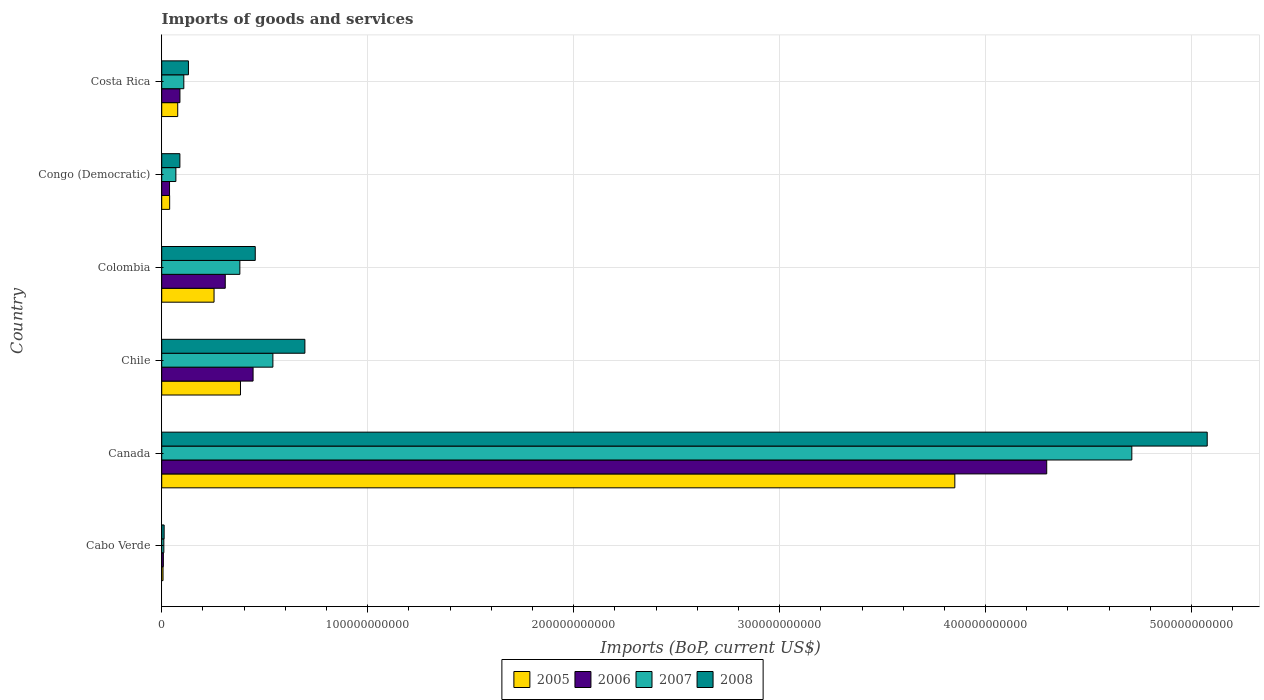What is the label of the 4th group of bars from the top?
Your answer should be compact. Chile. What is the amount spent on imports in 2006 in Colombia?
Provide a succinct answer. 3.09e+1. Across all countries, what is the maximum amount spent on imports in 2006?
Your answer should be compact. 4.30e+11. Across all countries, what is the minimum amount spent on imports in 2008?
Keep it short and to the point. 1.18e+09. In which country was the amount spent on imports in 2006 minimum?
Give a very brief answer. Cabo Verde. What is the total amount spent on imports in 2005 in the graph?
Make the answer very short. 4.61e+11. What is the difference between the amount spent on imports in 2006 in Canada and that in Congo (Democratic)?
Your answer should be compact. 4.26e+11. What is the difference between the amount spent on imports in 2008 in Cabo Verde and the amount spent on imports in 2005 in Canada?
Offer a terse response. -3.84e+11. What is the average amount spent on imports in 2006 per country?
Keep it short and to the point. 8.64e+1. What is the difference between the amount spent on imports in 2008 and amount spent on imports in 2005 in Canada?
Make the answer very short. 1.23e+11. In how many countries, is the amount spent on imports in 2008 greater than 200000000000 US$?
Provide a succinct answer. 1. What is the ratio of the amount spent on imports in 2006 in Chile to that in Colombia?
Keep it short and to the point. 1.44. Is the amount spent on imports in 2008 in Canada less than that in Chile?
Ensure brevity in your answer.  No. What is the difference between the highest and the second highest amount spent on imports in 2008?
Your response must be concise. 4.38e+11. What is the difference between the highest and the lowest amount spent on imports in 2006?
Ensure brevity in your answer.  4.29e+11. What does the 4th bar from the top in Chile represents?
Provide a succinct answer. 2005. Is it the case that in every country, the sum of the amount spent on imports in 2007 and amount spent on imports in 2008 is greater than the amount spent on imports in 2005?
Offer a very short reply. Yes. How many countries are there in the graph?
Give a very brief answer. 6. What is the difference between two consecutive major ticks on the X-axis?
Provide a short and direct response. 1.00e+11. Does the graph contain grids?
Your response must be concise. Yes. How many legend labels are there?
Give a very brief answer. 4. What is the title of the graph?
Provide a short and direct response. Imports of goods and services. What is the label or title of the X-axis?
Offer a terse response. Imports (BoP, current US$). What is the label or title of the Y-axis?
Keep it short and to the point. Country. What is the Imports (BoP, current US$) in 2005 in Cabo Verde?
Keep it short and to the point. 6.42e+08. What is the Imports (BoP, current US$) in 2006 in Cabo Verde?
Offer a terse response. 8.04e+08. What is the Imports (BoP, current US$) of 2007 in Cabo Verde?
Your response must be concise. 1.03e+09. What is the Imports (BoP, current US$) of 2008 in Cabo Verde?
Your answer should be very brief. 1.18e+09. What is the Imports (BoP, current US$) in 2005 in Canada?
Your answer should be compact. 3.85e+11. What is the Imports (BoP, current US$) of 2006 in Canada?
Offer a very short reply. 4.30e+11. What is the Imports (BoP, current US$) in 2007 in Canada?
Your response must be concise. 4.71e+11. What is the Imports (BoP, current US$) in 2008 in Canada?
Provide a succinct answer. 5.08e+11. What is the Imports (BoP, current US$) in 2005 in Chile?
Your answer should be compact. 3.82e+1. What is the Imports (BoP, current US$) in 2006 in Chile?
Provide a short and direct response. 4.44e+1. What is the Imports (BoP, current US$) of 2007 in Chile?
Provide a succinct answer. 5.40e+1. What is the Imports (BoP, current US$) in 2008 in Chile?
Ensure brevity in your answer.  6.95e+1. What is the Imports (BoP, current US$) of 2005 in Colombia?
Provide a short and direct response. 2.54e+1. What is the Imports (BoP, current US$) in 2006 in Colombia?
Your response must be concise. 3.09e+1. What is the Imports (BoP, current US$) of 2007 in Colombia?
Your answer should be compact. 3.79e+1. What is the Imports (BoP, current US$) in 2008 in Colombia?
Your answer should be very brief. 4.54e+1. What is the Imports (BoP, current US$) of 2005 in Congo (Democratic)?
Your response must be concise. 3.86e+09. What is the Imports (BoP, current US$) in 2006 in Congo (Democratic)?
Keep it short and to the point. 3.80e+09. What is the Imports (BoP, current US$) of 2007 in Congo (Democratic)?
Ensure brevity in your answer.  6.87e+09. What is the Imports (BoP, current US$) in 2008 in Congo (Democratic)?
Offer a very short reply. 8.83e+09. What is the Imports (BoP, current US$) of 2005 in Costa Rica?
Provide a short and direct response. 7.77e+09. What is the Imports (BoP, current US$) of 2006 in Costa Rica?
Your response must be concise. 8.85e+09. What is the Imports (BoP, current US$) in 2007 in Costa Rica?
Your answer should be compact. 1.07e+1. What is the Imports (BoP, current US$) of 2008 in Costa Rica?
Provide a succinct answer. 1.30e+1. Across all countries, what is the maximum Imports (BoP, current US$) in 2005?
Give a very brief answer. 3.85e+11. Across all countries, what is the maximum Imports (BoP, current US$) in 2006?
Your response must be concise. 4.30e+11. Across all countries, what is the maximum Imports (BoP, current US$) in 2007?
Your response must be concise. 4.71e+11. Across all countries, what is the maximum Imports (BoP, current US$) of 2008?
Make the answer very short. 5.08e+11. Across all countries, what is the minimum Imports (BoP, current US$) of 2005?
Provide a short and direct response. 6.42e+08. Across all countries, what is the minimum Imports (BoP, current US$) of 2006?
Offer a terse response. 8.04e+08. Across all countries, what is the minimum Imports (BoP, current US$) in 2007?
Provide a short and direct response. 1.03e+09. Across all countries, what is the minimum Imports (BoP, current US$) of 2008?
Provide a succinct answer. 1.18e+09. What is the total Imports (BoP, current US$) of 2005 in the graph?
Give a very brief answer. 4.61e+11. What is the total Imports (BoP, current US$) in 2006 in the graph?
Give a very brief answer. 5.18e+11. What is the total Imports (BoP, current US$) of 2007 in the graph?
Provide a short and direct response. 5.82e+11. What is the total Imports (BoP, current US$) in 2008 in the graph?
Keep it short and to the point. 6.46e+11. What is the difference between the Imports (BoP, current US$) of 2005 in Cabo Verde and that in Canada?
Ensure brevity in your answer.  -3.84e+11. What is the difference between the Imports (BoP, current US$) in 2006 in Cabo Verde and that in Canada?
Keep it short and to the point. -4.29e+11. What is the difference between the Imports (BoP, current US$) of 2007 in Cabo Verde and that in Canada?
Keep it short and to the point. -4.70e+11. What is the difference between the Imports (BoP, current US$) in 2008 in Cabo Verde and that in Canada?
Make the answer very short. -5.06e+11. What is the difference between the Imports (BoP, current US$) of 2005 in Cabo Verde and that in Chile?
Make the answer very short. -3.76e+1. What is the difference between the Imports (BoP, current US$) in 2006 in Cabo Verde and that in Chile?
Provide a short and direct response. -4.36e+1. What is the difference between the Imports (BoP, current US$) in 2007 in Cabo Verde and that in Chile?
Keep it short and to the point. -5.29e+1. What is the difference between the Imports (BoP, current US$) of 2008 in Cabo Verde and that in Chile?
Provide a short and direct response. -6.83e+1. What is the difference between the Imports (BoP, current US$) of 2005 in Cabo Verde and that in Colombia?
Offer a terse response. -2.48e+1. What is the difference between the Imports (BoP, current US$) in 2006 in Cabo Verde and that in Colombia?
Offer a terse response. -3.00e+1. What is the difference between the Imports (BoP, current US$) in 2007 in Cabo Verde and that in Colombia?
Give a very brief answer. -3.69e+1. What is the difference between the Imports (BoP, current US$) of 2008 in Cabo Verde and that in Colombia?
Your answer should be very brief. -4.42e+1. What is the difference between the Imports (BoP, current US$) in 2005 in Cabo Verde and that in Congo (Democratic)?
Your response must be concise. -3.22e+09. What is the difference between the Imports (BoP, current US$) of 2006 in Cabo Verde and that in Congo (Democratic)?
Give a very brief answer. -2.99e+09. What is the difference between the Imports (BoP, current US$) in 2007 in Cabo Verde and that in Congo (Democratic)?
Give a very brief answer. -5.84e+09. What is the difference between the Imports (BoP, current US$) of 2008 in Cabo Verde and that in Congo (Democratic)?
Your answer should be compact. -7.64e+09. What is the difference between the Imports (BoP, current US$) of 2005 in Cabo Verde and that in Costa Rica?
Provide a succinct answer. -7.13e+09. What is the difference between the Imports (BoP, current US$) in 2006 in Cabo Verde and that in Costa Rica?
Offer a very short reply. -8.04e+09. What is the difference between the Imports (BoP, current US$) in 2007 in Cabo Verde and that in Costa Rica?
Give a very brief answer. -9.69e+09. What is the difference between the Imports (BoP, current US$) in 2008 in Cabo Verde and that in Costa Rica?
Offer a very short reply. -1.18e+1. What is the difference between the Imports (BoP, current US$) in 2005 in Canada and that in Chile?
Your response must be concise. 3.47e+11. What is the difference between the Imports (BoP, current US$) in 2006 in Canada and that in Chile?
Your answer should be compact. 3.85e+11. What is the difference between the Imports (BoP, current US$) in 2007 in Canada and that in Chile?
Your response must be concise. 4.17e+11. What is the difference between the Imports (BoP, current US$) in 2008 in Canada and that in Chile?
Your answer should be compact. 4.38e+11. What is the difference between the Imports (BoP, current US$) in 2005 in Canada and that in Colombia?
Keep it short and to the point. 3.60e+11. What is the difference between the Imports (BoP, current US$) in 2006 in Canada and that in Colombia?
Provide a succinct answer. 3.99e+11. What is the difference between the Imports (BoP, current US$) in 2007 in Canada and that in Colombia?
Your answer should be very brief. 4.33e+11. What is the difference between the Imports (BoP, current US$) in 2008 in Canada and that in Colombia?
Keep it short and to the point. 4.62e+11. What is the difference between the Imports (BoP, current US$) of 2005 in Canada and that in Congo (Democratic)?
Your response must be concise. 3.81e+11. What is the difference between the Imports (BoP, current US$) in 2006 in Canada and that in Congo (Democratic)?
Give a very brief answer. 4.26e+11. What is the difference between the Imports (BoP, current US$) of 2007 in Canada and that in Congo (Democratic)?
Your answer should be compact. 4.64e+11. What is the difference between the Imports (BoP, current US$) of 2008 in Canada and that in Congo (Democratic)?
Your response must be concise. 4.99e+11. What is the difference between the Imports (BoP, current US$) in 2005 in Canada and that in Costa Rica?
Your response must be concise. 3.77e+11. What is the difference between the Imports (BoP, current US$) of 2006 in Canada and that in Costa Rica?
Ensure brevity in your answer.  4.21e+11. What is the difference between the Imports (BoP, current US$) of 2007 in Canada and that in Costa Rica?
Offer a terse response. 4.60e+11. What is the difference between the Imports (BoP, current US$) of 2008 in Canada and that in Costa Rica?
Provide a succinct answer. 4.95e+11. What is the difference between the Imports (BoP, current US$) in 2005 in Chile and that in Colombia?
Make the answer very short. 1.28e+1. What is the difference between the Imports (BoP, current US$) of 2006 in Chile and that in Colombia?
Provide a short and direct response. 1.35e+1. What is the difference between the Imports (BoP, current US$) of 2007 in Chile and that in Colombia?
Ensure brevity in your answer.  1.60e+1. What is the difference between the Imports (BoP, current US$) of 2008 in Chile and that in Colombia?
Provide a succinct answer. 2.41e+1. What is the difference between the Imports (BoP, current US$) of 2005 in Chile and that in Congo (Democratic)?
Offer a terse response. 3.44e+1. What is the difference between the Imports (BoP, current US$) of 2006 in Chile and that in Congo (Democratic)?
Make the answer very short. 4.06e+1. What is the difference between the Imports (BoP, current US$) in 2007 in Chile and that in Congo (Democratic)?
Give a very brief answer. 4.71e+1. What is the difference between the Imports (BoP, current US$) in 2008 in Chile and that in Congo (Democratic)?
Give a very brief answer. 6.07e+1. What is the difference between the Imports (BoP, current US$) of 2005 in Chile and that in Costa Rica?
Offer a very short reply. 3.05e+1. What is the difference between the Imports (BoP, current US$) of 2006 in Chile and that in Costa Rica?
Provide a succinct answer. 3.55e+1. What is the difference between the Imports (BoP, current US$) in 2007 in Chile and that in Costa Rica?
Keep it short and to the point. 4.33e+1. What is the difference between the Imports (BoP, current US$) of 2008 in Chile and that in Costa Rica?
Your answer should be very brief. 5.65e+1. What is the difference between the Imports (BoP, current US$) of 2005 in Colombia and that in Congo (Democratic)?
Provide a succinct answer. 2.16e+1. What is the difference between the Imports (BoP, current US$) in 2006 in Colombia and that in Congo (Democratic)?
Provide a short and direct response. 2.71e+1. What is the difference between the Imports (BoP, current US$) in 2007 in Colombia and that in Congo (Democratic)?
Offer a terse response. 3.11e+1. What is the difference between the Imports (BoP, current US$) in 2008 in Colombia and that in Congo (Democratic)?
Provide a short and direct response. 3.66e+1. What is the difference between the Imports (BoP, current US$) of 2005 in Colombia and that in Costa Rica?
Ensure brevity in your answer.  1.76e+1. What is the difference between the Imports (BoP, current US$) in 2006 in Colombia and that in Costa Rica?
Offer a very short reply. 2.20e+1. What is the difference between the Imports (BoP, current US$) in 2007 in Colombia and that in Costa Rica?
Offer a very short reply. 2.72e+1. What is the difference between the Imports (BoP, current US$) of 2008 in Colombia and that in Costa Rica?
Your answer should be compact. 3.24e+1. What is the difference between the Imports (BoP, current US$) in 2005 in Congo (Democratic) and that in Costa Rica?
Provide a succinct answer. -3.91e+09. What is the difference between the Imports (BoP, current US$) in 2006 in Congo (Democratic) and that in Costa Rica?
Keep it short and to the point. -5.05e+09. What is the difference between the Imports (BoP, current US$) in 2007 in Congo (Democratic) and that in Costa Rica?
Make the answer very short. -3.85e+09. What is the difference between the Imports (BoP, current US$) in 2008 in Congo (Democratic) and that in Costa Rica?
Give a very brief answer. -4.15e+09. What is the difference between the Imports (BoP, current US$) of 2005 in Cabo Verde and the Imports (BoP, current US$) of 2006 in Canada?
Your answer should be very brief. -4.29e+11. What is the difference between the Imports (BoP, current US$) in 2005 in Cabo Verde and the Imports (BoP, current US$) in 2007 in Canada?
Offer a terse response. -4.70e+11. What is the difference between the Imports (BoP, current US$) of 2005 in Cabo Verde and the Imports (BoP, current US$) of 2008 in Canada?
Offer a terse response. -5.07e+11. What is the difference between the Imports (BoP, current US$) of 2006 in Cabo Verde and the Imports (BoP, current US$) of 2007 in Canada?
Offer a very short reply. -4.70e+11. What is the difference between the Imports (BoP, current US$) in 2006 in Cabo Verde and the Imports (BoP, current US$) in 2008 in Canada?
Provide a short and direct response. -5.07e+11. What is the difference between the Imports (BoP, current US$) of 2007 in Cabo Verde and the Imports (BoP, current US$) of 2008 in Canada?
Provide a succinct answer. -5.07e+11. What is the difference between the Imports (BoP, current US$) in 2005 in Cabo Verde and the Imports (BoP, current US$) in 2006 in Chile?
Make the answer very short. -4.37e+1. What is the difference between the Imports (BoP, current US$) of 2005 in Cabo Verde and the Imports (BoP, current US$) of 2007 in Chile?
Make the answer very short. -5.33e+1. What is the difference between the Imports (BoP, current US$) in 2005 in Cabo Verde and the Imports (BoP, current US$) in 2008 in Chile?
Give a very brief answer. -6.89e+1. What is the difference between the Imports (BoP, current US$) of 2006 in Cabo Verde and the Imports (BoP, current US$) of 2007 in Chile?
Provide a short and direct response. -5.32e+1. What is the difference between the Imports (BoP, current US$) of 2006 in Cabo Verde and the Imports (BoP, current US$) of 2008 in Chile?
Your answer should be very brief. -6.87e+1. What is the difference between the Imports (BoP, current US$) of 2007 in Cabo Verde and the Imports (BoP, current US$) of 2008 in Chile?
Provide a succinct answer. -6.85e+1. What is the difference between the Imports (BoP, current US$) of 2005 in Cabo Verde and the Imports (BoP, current US$) of 2006 in Colombia?
Keep it short and to the point. -3.02e+1. What is the difference between the Imports (BoP, current US$) in 2005 in Cabo Verde and the Imports (BoP, current US$) in 2007 in Colombia?
Your answer should be compact. -3.73e+1. What is the difference between the Imports (BoP, current US$) of 2005 in Cabo Verde and the Imports (BoP, current US$) of 2008 in Colombia?
Offer a very short reply. -4.48e+1. What is the difference between the Imports (BoP, current US$) in 2006 in Cabo Verde and the Imports (BoP, current US$) in 2007 in Colombia?
Provide a short and direct response. -3.71e+1. What is the difference between the Imports (BoP, current US$) of 2006 in Cabo Verde and the Imports (BoP, current US$) of 2008 in Colombia?
Your response must be concise. -4.46e+1. What is the difference between the Imports (BoP, current US$) of 2007 in Cabo Verde and the Imports (BoP, current US$) of 2008 in Colombia?
Provide a short and direct response. -4.44e+1. What is the difference between the Imports (BoP, current US$) in 2005 in Cabo Verde and the Imports (BoP, current US$) in 2006 in Congo (Democratic)?
Provide a succinct answer. -3.16e+09. What is the difference between the Imports (BoP, current US$) in 2005 in Cabo Verde and the Imports (BoP, current US$) in 2007 in Congo (Democratic)?
Offer a terse response. -6.23e+09. What is the difference between the Imports (BoP, current US$) of 2005 in Cabo Verde and the Imports (BoP, current US$) of 2008 in Congo (Democratic)?
Your answer should be compact. -8.18e+09. What is the difference between the Imports (BoP, current US$) of 2006 in Cabo Verde and the Imports (BoP, current US$) of 2007 in Congo (Democratic)?
Offer a very short reply. -6.07e+09. What is the difference between the Imports (BoP, current US$) of 2006 in Cabo Verde and the Imports (BoP, current US$) of 2008 in Congo (Democratic)?
Offer a very short reply. -8.02e+09. What is the difference between the Imports (BoP, current US$) of 2007 in Cabo Verde and the Imports (BoP, current US$) of 2008 in Congo (Democratic)?
Provide a short and direct response. -7.79e+09. What is the difference between the Imports (BoP, current US$) of 2005 in Cabo Verde and the Imports (BoP, current US$) of 2006 in Costa Rica?
Provide a short and direct response. -8.20e+09. What is the difference between the Imports (BoP, current US$) of 2005 in Cabo Verde and the Imports (BoP, current US$) of 2007 in Costa Rica?
Your answer should be very brief. -1.01e+1. What is the difference between the Imports (BoP, current US$) in 2005 in Cabo Verde and the Imports (BoP, current US$) in 2008 in Costa Rica?
Your answer should be very brief. -1.23e+1. What is the difference between the Imports (BoP, current US$) in 2006 in Cabo Verde and the Imports (BoP, current US$) in 2007 in Costa Rica?
Give a very brief answer. -9.92e+09. What is the difference between the Imports (BoP, current US$) of 2006 in Cabo Verde and the Imports (BoP, current US$) of 2008 in Costa Rica?
Give a very brief answer. -1.22e+1. What is the difference between the Imports (BoP, current US$) in 2007 in Cabo Verde and the Imports (BoP, current US$) in 2008 in Costa Rica?
Your answer should be compact. -1.19e+1. What is the difference between the Imports (BoP, current US$) in 2005 in Canada and the Imports (BoP, current US$) in 2006 in Chile?
Provide a succinct answer. 3.41e+11. What is the difference between the Imports (BoP, current US$) in 2005 in Canada and the Imports (BoP, current US$) in 2007 in Chile?
Provide a short and direct response. 3.31e+11. What is the difference between the Imports (BoP, current US$) in 2005 in Canada and the Imports (BoP, current US$) in 2008 in Chile?
Make the answer very short. 3.16e+11. What is the difference between the Imports (BoP, current US$) in 2006 in Canada and the Imports (BoP, current US$) in 2007 in Chile?
Give a very brief answer. 3.76e+11. What is the difference between the Imports (BoP, current US$) of 2006 in Canada and the Imports (BoP, current US$) of 2008 in Chile?
Your answer should be compact. 3.60e+11. What is the difference between the Imports (BoP, current US$) in 2007 in Canada and the Imports (BoP, current US$) in 2008 in Chile?
Provide a short and direct response. 4.01e+11. What is the difference between the Imports (BoP, current US$) of 2005 in Canada and the Imports (BoP, current US$) of 2006 in Colombia?
Keep it short and to the point. 3.54e+11. What is the difference between the Imports (BoP, current US$) of 2005 in Canada and the Imports (BoP, current US$) of 2007 in Colombia?
Provide a succinct answer. 3.47e+11. What is the difference between the Imports (BoP, current US$) of 2005 in Canada and the Imports (BoP, current US$) of 2008 in Colombia?
Provide a short and direct response. 3.40e+11. What is the difference between the Imports (BoP, current US$) in 2006 in Canada and the Imports (BoP, current US$) in 2007 in Colombia?
Provide a succinct answer. 3.92e+11. What is the difference between the Imports (BoP, current US$) in 2006 in Canada and the Imports (BoP, current US$) in 2008 in Colombia?
Give a very brief answer. 3.84e+11. What is the difference between the Imports (BoP, current US$) in 2007 in Canada and the Imports (BoP, current US$) in 2008 in Colombia?
Give a very brief answer. 4.26e+11. What is the difference between the Imports (BoP, current US$) in 2005 in Canada and the Imports (BoP, current US$) in 2006 in Congo (Democratic)?
Offer a very short reply. 3.81e+11. What is the difference between the Imports (BoP, current US$) of 2005 in Canada and the Imports (BoP, current US$) of 2007 in Congo (Democratic)?
Give a very brief answer. 3.78e+11. What is the difference between the Imports (BoP, current US$) of 2005 in Canada and the Imports (BoP, current US$) of 2008 in Congo (Democratic)?
Your answer should be very brief. 3.76e+11. What is the difference between the Imports (BoP, current US$) in 2006 in Canada and the Imports (BoP, current US$) in 2007 in Congo (Democratic)?
Your answer should be very brief. 4.23e+11. What is the difference between the Imports (BoP, current US$) in 2006 in Canada and the Imports (BoP, current US$) in 2008 in Congo (Democratic)?
Make the answer very short. 4.21e+11. What is the difference between the Imports (BoP, current US$) in 2007 in Canada and the Imports (BoP, current US$) in 2008 in Congo (Democratic)?
Keep it short and to the point. 4.62e+11. What is the difference between the Imports (BoP, current US$) of 2005 in Canada and the Imports (BoP, current US$) of 2006 in Costa Rica?
Give a very brief answer. 3.76e+11. What is the difference between the Imports (BoP, current US$) of 2005 in Canada and the Imports (BoP, current US$) of 2007 in Costa Rica?
Ensure brevity in your answer.  3.74e+11. What is the difference between the Imports (BoP, current US$) of 2005 in Canada and the Imports (BoP, current US$) of 2008 in Costa Rica?
Offer a terse response. 3.72e+11. What is the difference between the Imports (BoP, current US$) of 2006 in Canada and the Imports (BoP, current US$) of 2007 in Costa Rica?
Offer a very short reply. 4.19e+11. What is the difference between the Imports (BoP, current US$) in 2006 in Canada and the Imports (BoP, current US$) in 2008 in Costa Rica?
Provide a succinct answer. 4.17e+11. What is the difference between the Imports (BoP, current US$) in 2007 in Canada and the Imports (BoP, current US$) in 2008 in Costa Rica?
Offer a very short reply. 4.58e+11. What is the difference between the Imports (BoP, current US$) of 2005 in Chile and the Imports (BoP, current US$) of 2006 in Colombia?
Your response must be concise. 7.40e+09. What is the difference between the Imports (BoP, current US$) in 2005 in Chile and the Imports (BoP, current US$) in 2007 in Colombia?
Your answer should be very brief. 3.07e+08. What is the difference between the Imports (BoP, current US$) of 2005 in Chile and the Imports (BoP, current US$) of 2008 in Colombia?
Your answer should be compact. -7.17e+09. What is the difference between the Imports (BoP, current US$) of 2006 in Chile and the Imports (BoP, current US$) of 2007 in Colombia?
Your answer should be compact. 6.42e+09. What is the difference between the Imports (BoP, current US$) in 2006 in Chile and the Imports (BoP, current US$) in 2008 in Colombia?
Your response must be concise. -1.05e+09. What is the difference between the Imports (BoP, current US$) of 2007 in Chile and the Imports (BoP, current US$) of 2008 in Colombia?
Provide a short and direct response. 8.57e+09. What is the difference between the Imports (BoP, current US$) in 2005 in Chile and the Imports (BoP, current US$) in 2006 in Congo (Democratic)?
Your answer should be compact. 3.45e+1. What is the difference between the Imports (BoP, current US$) of 2005 in Chile and the Imports (BoP, current US$) of 2007 in Congo (Democratic)?
Ensure brevity in your answer.  3.14e+1. What is the difference between the Imports (BoP, current US$) of 2005 in Chile and the Imports (BoP, current US$) of 2008 in Congo (Democratic)?
Your answer should be compact. 2.94e+1. What is the difference between the Imports (BoP, current US$) of 2006 in Chile and the Imports (BoP, current US$) of 2007 in Congo (Democratic)?
Make the answer very short. 3.75e+1. What is the difference between the Imports (BoP, current US$) in 2006 in Chile and the Imports (BoP, current US$) in 2008 in Congo (Democratic)?
Offer a terse response. 3.55e+1. What is the difference between the Imports (BoP, current US$) in 2007 in Chile and the Imports (BoP, current US$) in 2008 in Congo (Democratic)?
Provide a succinct answer. 4.52e+1. What is the difference between the Imports (BoP, current US$) of 2005 in Chile and the Imports (BoP, current US$) of 2006 in Costa Rica?
Ensure brevity in your answer.  2.94e+1. What is the difference between the Imports (BoP, current US$) of 2005 in Chile and the Imports (BoP, current US$) of 2007 in Costa Rica?
Keep it short and to the point. 2.75e+1. What is the difference between the Imports (BoP, current US$) in 2005 in Chile and the Imports (BoP, current US$) in 2008 in Costa Rica?
Keep it short and to the point. 2.53e+1. What is the difference between the Imports (BoP, current US$) in 2006 in Chile and the Imports (BoP, current US$) in 2007 in Costa Rica?
Give a very brief answer. 3.36e+1. What is the difference between the Imports (BoP, current US$) in 2006 in Chile and the Imports (BoP, current US$) in 2008 in Costa Rica?
Ensure brevity in your answer.  3.14e+1. What is the difference between the Imports (BoP, current US$) of 2007 in Chile and the Imports (BoP, current US$) of 2008 in Costa Rica?
Your answer should be very brief. 4.10e+1. What is the difference between the Imports (BoP, current US$) of 2005 in Colombia and the Imports (BoP, current US$) of 2006 in Congo (Democratic)?
Offer a very short reply. 2.16e+1. What is the difference between the Imports (BoP, current US$) in 2005 in Colombia and the Imports (BoP, current US$) in 2007 in Congo (Democratic)?
Provide a short and direct response. 1.85e+1. What is the difference between the Imports (BoP, current US$) in 2005 in Colombia and the Imports (BoP, current US$) in 2008 in Congo (Democratic)?
Your response must be concise. 1.66e+1. What is the difference between the Imports (BoP, current US$) of 2006 in Colombia and the Imports (BoP, current US$) of 2007 in Congo (Democratic)?
Offer a terse response. 2.40e+1. What is the difference between the Imports (BoP, current US$) in 2006 in Colombia and the Imports (BoP, current US$) in 2008 in Congo (Democratic)?
Your answer should be very brief. 2.20e+1. What is the difference between the Imports (BoP, current US$) in 2007 in Colombia and the Imports (BoP, current US$) in 2008 in Congo (Democratic)?
Ensure brevity in your answer.  2.91e+1. What is the difference between the Imports (BoP, current US$) of 2005 in Colombia and the Imports (BoP, current US$) of 2006 in Costa Rica?
Provide a short and direct response. 1.66e+1. What is the difference between the Imports (BoP, current US$) of 2005 in Colombia and the Imports (BoP, current US$) of 2007 in Costa Rica?
Offer a very short reply. 1.47e+1. What is the difference between the Imports (BoP, current US$) in 2005 in Colombia and the Imports (BoP, current US$) in 2008 in Costa Rica?
Offer a very short reply. 1.24e+1. What is the difference between the Imports (BoP, current US$) of 2006 in Colombia and the Imports (BoP, current US$) of 2007 in Costa Rica?
Offer a terse response. 2.01e+1. What is the difference between the Imports (BoP, current US$) in 2006 in Colombia and the Imports (BoP, current US$) in 2008 in Costa Rica?
Your answer should be very brief. 1.79e+1. What is the difference between the Imports (BoP, current US$) in 2007 in Colombia and the Imports (BoP, current US$) in 2008 in Costa Rica?
Give a very brief answer. 2.50e+1. What is the difference between the Imports (BoP, current US$) of 2005 in Congo (Democratic) and the Imports (BoP, current US$) of 2006 in Costa Rica?
Provide a succinct answer. -4.99e+09. What is the difference between the Imports (BoP, current US$) of 2005 in Congo (Democratic) and the Imports (BoP, current US$) of 2007 in Costa Rica?
Offer a terse response. -6.87e+09. What is the difference between the Imports (BoP, current US$) of 2005 in Congo (Democratic) and the Imports (BoP, current US$) of 2008 in Costa Rica?
Your response must be concise. -9.12e+09. What is the difference between the Imports (BoP, current US$) of 2006 in Congo (Democratic) and the Imports (BoP, current US$) of 2007 in Costa Rica?
Your answer should be compact. -6.93e+09. What is the difference between the Imports (BoP, current US$) in 2006 in Congo (Democratic) and the Imports (BoP, current US$) in 2008 in Costa Rica?
Make the answer very short. -9.18e+09. What is the difference between the Imports (BoP, current US$) in 2007 in Congo (Democratic) and the Imports (BoP, current US$) in 2008 in Costa Rica?
Provide a short and direct response. -6.10e+09. What is the average Imports (BoP, current US$) in 2005 per country?
Your answer should be very brief. 7.68e+1. What is the average Imports (BoP, current US$) in 2006 per country?
Provide a short and direct response. 8.64e+1. What is the average Imports (BoP, current US$) in 2007 per country?
Your answer should be compact. 9.69e+1. What is the average Imports (BoP, current US$) of 2008 per country?
Provide a short and direct response. 1.08e+11. What is the difference between the Imports (BoP, current US$) of 2005 and Imports (BoP, current US$) of 2006 in Cabo Verde?
Offer a very short reply. -1.62e+08. What is the difference between the Imports (BoP, current US$) of 2005 and Imports (BoP, current US$) of 2007 in Cabo Verde?
Provide a short and direct response. -3.92e+08. What is the difference between the Imports (BoP, current US$) in 2005 and Imports (BoP, current US$) in 2008 in Cabo Verde?
Offer a terse response. -5.41e+08. What is the difference between the Imports (BoP, current US$) of 2006 and Imports (BoP, current US$) of 2007 in Cabo Verde?
Your answer should be very brief. -2.30e+08. What is the difference between the Imports (BoP, current US$) in 2006 and Imports (BoP, current US$) in 2008 in Cabo Verde?
Offer a very short reply. -3.79e+08. What is the difference between the Imports (BoP, current US$) in 2007 and Imports (BoP, current US$) in 2008 in Cabo Verde?
Your answer should be very brief. -1.50e+08. What is the difference between the Imports (BoP, current US$) of 2005 and Imports (BoP, current US$) of 2006 in Canada?
Your answer should be compact. -4.46e+1. What is the difference between the Imports (BoP, current US$) in 2005 and Imports (BoP, current US$) in 2007 in Canada?
Offer a terse response. -8.59e+1. What is the difference between the Imports (BoP, current US$) of 2005 and Imports (BoP, current US$) of 2008 in Canada?
Offer a terse response. -1.23e+11. What is the difference between the Imports (BoP, current US$) in 2006 and Imports (BoP, current US$) in 2007 in Canada?
Provide a succinct answer. -4.13e+1. What is the difference between the Imports (BoP, current US$) of 2006 and Imports (BoP, current US$) of 2008 in Canada?
Give a very brief answer. -7.79e+1. What is the difference between the Imports (BoP, current US$) of 2007 and Imports (BoP, current US$) of 2008 in Canada?
Provide a short and direct response. -3.66e+1. What is the difference between the Imports (BoP, current US$) in 2005 and Imports (BoP, current US$) in 2006 in Chile?
Your answer should be very brief. -6.11e+09. What is the difference between the Imports (BoP, current US$) in 2005 and Imports (BoP, current US$) in 2007 in Chile?
Provide a short and direct response. -1.57e+1. What is the difference between the Imports (BoP, current US$) in 2005 and Imports (BoP, current US$) in 2008 in Chile?
Offer a terse response. -3.13e+1. What is the difference between the Imports (BoP, current US$) in 2006 and Imports (BoP, current US$) in 2007 in Chile?
Offer a terse response. -9.62e+09. What is the difference between the Imports (BoP, current US$) in 2006 and Imports (BoP, current US$) in 2008 in Chile?
Ensure brevity in your answer.  -2.52e+1. What is the difference between the Imports (BoP, current US$) of 2007 and Imports (BoP, current US$) of 2008 in Chile?
Your answer should be compact. -1.55e+1. What is the difference between the Imports (BoP, current US$) in 2005 and Imports (BoP, current US$) in 2006 in Colombia?
Your answer should be very brief. -5.44e+09. What is the difference between the Imports (BoP, current US$) in 2005 and Imports (BoP, current US$) in 2007 in Colombia?
Offer a terse response. -1.25e+1. What is the difference between the Imports (BoP, current US$) in 2005 and Imports (BoP, current US$) in 2008 in Colombia?
Give a very brief answer. -2.00e+1. What is the difference between the Imports (BoP, current US$) in 2006 and Imports (BoP, current US$) in 2007 in Colombia?
Offer a terse response. -7.09e+09. What is the difference between the Imports (BoP, current US$) in 2006 and Imports (BoP, current US$) in 2008 in Colombia?
Provide a succinct answer. -1.46e+1. What is the difference between the Imports (BoP, current US$) in 2007 and Imports (BoP, current US$) in 2008 in Colombia?
Ensure brevity in your answer.  -7.47e+09. What is the difference between the Imports (BoP, current US$) of 2005 and Imports (BoP, current US$) of 2006 in Congo (Democratic)?
Give a very brief answer. 6.22e+07. What is the difference between the Imports (BoP, current US$) in 2005 and Imports (BoP, current US$) in 2007 in Congo (Democratic)?
Make the answer very short. -3.02e+09. What is the difference between the Imports (BoP, current US$) in 2005 and Imports (BoP, current US$) in 2008 in Congo (Democratic)?
Ensure brevity in your answer.  -4.97e+09. What is the difference between the Imports (BoP, current US$) of 2006 and Imports (BoP, current US$) of 2007 in Congo (Democratic)?
Provide a short and direct response. -3.08e+09. What is the difference between the Imports (BoP, current US$) of 2006 and Imports (BoP, current US$) of 2008 in Congo (Democratic)?
Provide a succinct answer. -5.03e+09. What is the difference between the Imports (BoP, current US$) in 2007 and Imports (BoP, current US$) in 2008 in Congo (Democratic)?
Provide a succinct answer. -1.95e+09. What is the difference between the Imports (BoP, current US$) of 2005 and Imports (BoP, current US$) of 2006 in Costa Rica?
Keep it short and to the point. -1.07e+09. What is the difference between the Imports (BoP, current US$) in 2005 and Imports (BoP, current US$) in 2007 in Costa Rica?
Provide a succinct answer. -2.96e+09. What is the difference between the Imports (BoP, current US$) of 2005 and Imports (BoP, current US$) of 2008 in Costa Rica?
Ensure brevity in your answer.  -5.21e+09. What is the difference between the Imports (BoP, current US$) of 2006 and Imports (BoP, current US$) of 2007 in Costa Rica?
Ensure brevity in your answer.  -1.88e+09. What is the difference between the Imports (BoP, current US$) in 2006 and Imports (BoP, current US$) in 2008 in Costa Rica?
Offer a terse response. -4.13e+09. What is the difference between the Imports (BoP, current US$) in 2007 and Imports (BoP, current US$) in 2008 in Costa Rica?
Your answer should be compact. -2.25e+09. What is the ratio of the Imports (BoP, current US$) of 2005 in Cabo Verde to that in Canada?
Offer a very short reply. 0. What is the ratio of the Imports (BoP, current US$) of 2006 in Cabo Verde to that in Canada?
Provide a succinct answer. 0. What is the ratio of the Imports (BoP, current US$) in 2007 in Cabo Verde to that in Canada?
Ensure brevity in your answer.  0. What is the ratio of the Imports (BoP, current US$) of 2008 in Cabo Verde to that in Canada?
Provide a short and direct response. 0. What is the ratio of the Imports (BoP, current US$) of 2005 in Cabo Verde to that in Chile?
Provide a succinct answer. 0.02. What is the ratio of the Imports (BoP, current US$) of 2006 in Cabo Verde to that in Chile?
Ensure brevity in your answer.  0.02. What is the ratio of the Imports (BoP, current US$) of 2007 in Cabo Verde to that in Chile?
Give a very brief answer. 0.02. What is the ratio of the Imports (BoP, current US$) in 2008 in Cabo Verde to that in Chile?
Provide a succinct answer. 0.02. What is the ratio of the Imports (BoP, current US$) in 2005 in Cabo Verde to that in Colombia?
Offer a terse response. 0.03. What is the ratio of the Imports (BoP, current US$) in 2006 in Cabo Verde to that in Colombia?
Provide a short and direct response. 0.03. What is the ratio of the Imports (BoP, current US$) of 2007 in Cabo Verde to that in Colombia?
Your answer should be very brief. 0.03. What is the ratio of the Imports (BoP, current US$) in 2008 in Cabo Verde to that in Colombia?
Offer a very short reply. 0.03. What is the ratio of the Imports (BoP, current US$) in 2005 in Cabo Verde to that in Congo (Democratic)?
Your answer should be very brief. 0.17. What is the ratio of the Imports (BoP, current US$) in 2006 in Cabo Verde to that in Congo (Democratic)?
Keep it short and to the point. 0.21. What is the ratio of the Imports (BoP, current US$) in 2007 in Cabo Verde to that in Congo (Democratic)?
Your answer should be compact. 0.15. What is the ratio of the Imports (BoP, current US$) in 2008 in Cabo Verde to that in Congo (Democratic)?
Keep it short and to the point. 0.13. What is the ratio of the Imports (BoP, current US$) of 2005 in Cabo Verde to that in Costa Rica?
Ensure brevity in your answer.  0.08. What is the ratio of the Imports (BoP, current US$) of 2006 in Cabo Verde to that in Costa Rica?
Your response must be concise. 0.09. What is the ratio of the Imports (BoP, current US$) in 2007 in Cabo Verde to that in Costa Rica?
Make the answer very short. 0.1. What is the ratio of the Imports (BoP, current US$) of 2008 in Cabo Verde to that in Costa Rica?
Keep it short and to the point. 0.09. What is the ratio of the Imports (BoP, current US$) in 2005 in Canada to that in Chile?
Provide a succinct answer. 10.07. What is the ratio of the Imports (BoP, current US$) of 2006 in Canada to that in Chile?
Your answer should be compact. 9.69. What is the ratio of the Imports (BoP, current US$) of 2007 in Canada to that in Chile?
Make the answer very short. 8.73. What is the ratio of the Imports (BoP, current US$) of 2008 in Canada to that in Chile?
Ensure brevity in your answer.  7.3. What is the ratio of the Imports (BoP, current US$) in 2005 in Canada to that in Colombia?
Ensure brevity in your answer.  15.15. What is the ratio of the Imports (BoP, current US$) of 2006 in Canada to that in Colombia?
Your answer should be compact. 13.93. What is the ratio of the Imports (BoP, current US$) in 2007 in Canada to that in Colombia?
Your answer should be very brief. 12.41. What is the ratio of the Imports (BoP, current US$) of 2008 in Canada to that in Colombia?
Your answer should be compact. 11.18. What is the ratio of the Imports (BoP, current US$) of 2005 in Canada to that in Congo (Democratic)?
Ensure brevity in your answer.  99.77. What is the ratio of the Imports (BoP, current US$) of 2006 in Canada to that in Congo (Democratic)?
Provide a succinct answer. 113.15. What is the ratio of the Imports (BoP, current US$) of 2007 in Canada to that in Congo (Democratic)?
Your answer should be very brief. 68.51. What is the ratio of the Imports (BoP, current US$) in 2008 in Canada to that in Congo (Democratic)?
Give a very brief answer. 57.52. What is the ratio of the Imports (BoP, current US$) of 2005 in Canada to that in Costa Rica?
Give a very brief answer. 49.55. What is the ratio of the Imports (BoP, current US$) of 2006 in Canada to that in Costa Rica?
Provide a succinct answer. 48.57. What is the ratio of the Imports (BoP, current US$) of 2007 in Canada to that in Costa Rica?
Provide a succinct answer. 43.9. What is the ratio of the Imports (BoP, current US$) of 2008 in Canada to that in Costa Rica?
Offer a terse response. 39.11. What is the ratio of the Imports (BoP, current US$) of 2005 in Chile to that in Colombia?
Keep it short and to the point. 1.51. What is the ratio of the Imports (BoP, current US$) in 2006 in Chile to that in Colombia?
Make the answer very short. 1.44. What is the ratio of the Imports (BoP, current US$) of 2007 in Chile to that in Colombia?
Give a very brief answer. 1.42. What is the ratio of the Imports (BoP, current US$) in 2008 in Chile to that in Colombia?
Keep it short and to the point. 1.53. What is the ratio of the Imports (BoP, current US$) of 2005 in Chile to that in Congo (Democratic)?
Give a very brief answer. 9.91. What is the ratio of the Imports (BoP, current US$) in 2006 in Chile to that in Congo (Democratic)?
Your response must be concise. 11.68. What is the ratio of the Imports (BoP, current US$) in 2007 in Chile to that in Congo (Democratic)?
Keep it short and to the point. 7.85. What is the ratio of the Imports (BoP, current US$) of 2008 in Chile to that in Congo (Democratic)?
Make the answer very short. 7.88. What is the ratio of the Imports (BoP, current US$) of 2005 in Chile to that in Costa Rica?
Keep it short and to the point. 4.92. What is the ratio of the Imports (BoP, current US$) of 2006 in Chile to that in Costa Rica?
Ensure brevity in your answer.  5.01. What is the ratio of the Imports (BoP, current US$) in 2007 in Chile to that in Costa Rica?
Your answer should be very brief. 5.03. What is the ratio of the Imports (BoP, current US$) in 2008 in Chile to that in Costa Rica?
Your answer should be very brief. 5.36. What is the ratio of the Imports (BoP, current US$) of 2005 in Colombia to that in Congo (Democratic)?
Offer a terse response. 6.58. What is the ratio of the Imports (BoP, current US$) in 2006 in Colombia to that in Congo (Democratic)?
Offer a very short reply. 8.12. What is the ratio of the Imports (BoP, current US$) in 2007 in Colombia to that in Congo (Democratic)?
Offer a terse response. 5.52. What is the ratio of the Imports (BoP, current US$) of 2008 in Colombia to that in Congo (Democratic)?
Your answer should be very brief. 5.15. What is the ratio of the Imports (BoP, current US$) of 2005 in Colombia to that in Costa Rica?
Your answer should be very brief. 3.27. What is the ratio of the Imports (BoP, current US$) of 2006 in Colombia to that in Costa Rica?
Keep it short and to the point. 3.49. What is the ratio of the Imports (BoP, current US$) in 2007 in Colombia to that in Costa Rica?
Make the answer very short. 3.54. What is the ratio of the Imports (BoP, current US$) in 2008 in Colombia to that in Costa Rica?
Keep it short and to the point. 3.5. What is the ratio of the Imports (BoP, current US$) of 2005 in Congo (Democratic) to that in Costa Rica?
Make the answer very short. 0.5. What is the ratio of the Imports (BoP, current US$) of 2006 in Congo (Democratic) to that in Costa Rica?
Give a very brief answer. 0.43. What is the ratio of the Imports (BoP, current US$) of 2007 in Congo (Democratic) to that in Costa Rica?
Your answer should be compact. 0.64. What is the ratio of the Imports (BoP, current US$) of 2008 in Congo (Democratic) to that in Costa Rica?
Offer a terse response. 0.68. What is the difference between the highest and the second highest Imports (BoP, current US$) of 2005?
Make the answer very short. 3.47e+11. What is the difference between the highest and the second highest Imports (BoP, current US$) in 2006?
Your response must be concise. 3.85e+11. What is the difference between the highest and the second highest Imports (BoP, current US$) in 2007?
Provide a short and direct response. 4.17e+11. What is the difference between the highest and the second highest Imports (BoP, current US$) in 2008?
Ensure brevity in your answer.  4.38e+11. What is the difference between the highest and the lowest Imports (BoP, current US$) of 2005?
Give a very brief answer. 3.84e+11. What is the difference between the highest and the lowest Imports (BoP, current US$) of 2006?
Offer a terse response. 4.29e+11. What is the difference between the highest and the lowest Imports (BoP, current US$) in 2007?
Provide a short and direct response. 4.70e+11. What is the difference between the highest and the lowest Imports (BoP, current US$) of 2008?
Make the answer very short. 5.06e+11. 